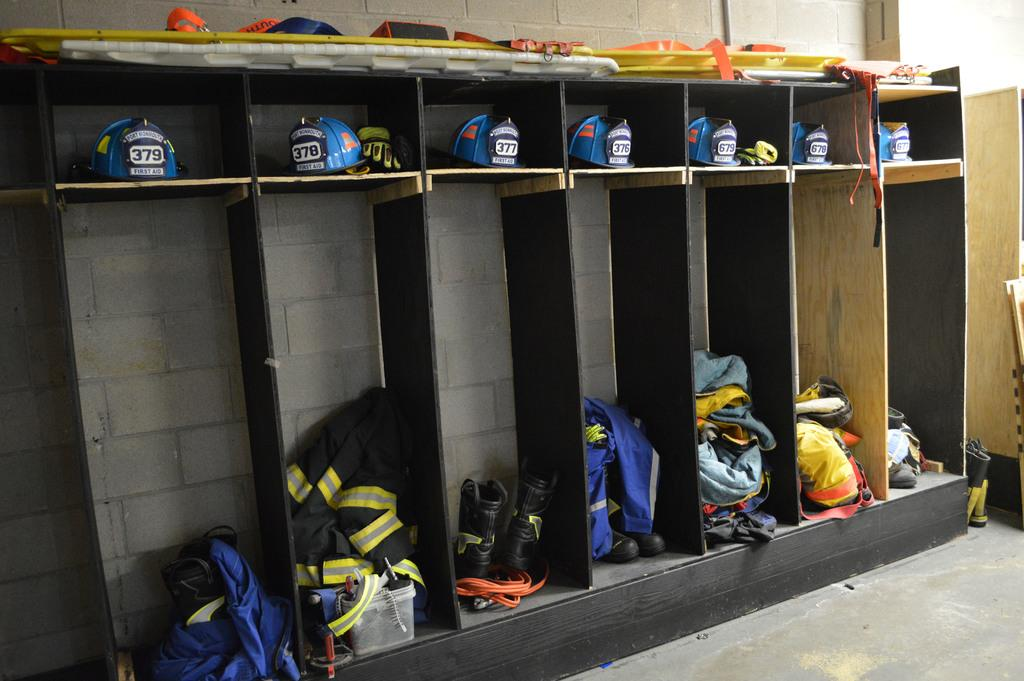What type of storage units are present in the image? The image contains cupboards. What items can be found inside the cupboards? Helmets, clothes, and shoes are stored in the cupboards. What is the surface beneath the cupboards? There is a floor at the bottom of the image. What can be seen in the background of the image? There is a wall in the background of the image. How does the kite help in the aftermath of the image? There is no kite present in the image, and therefore no such help can be provided or observed. 